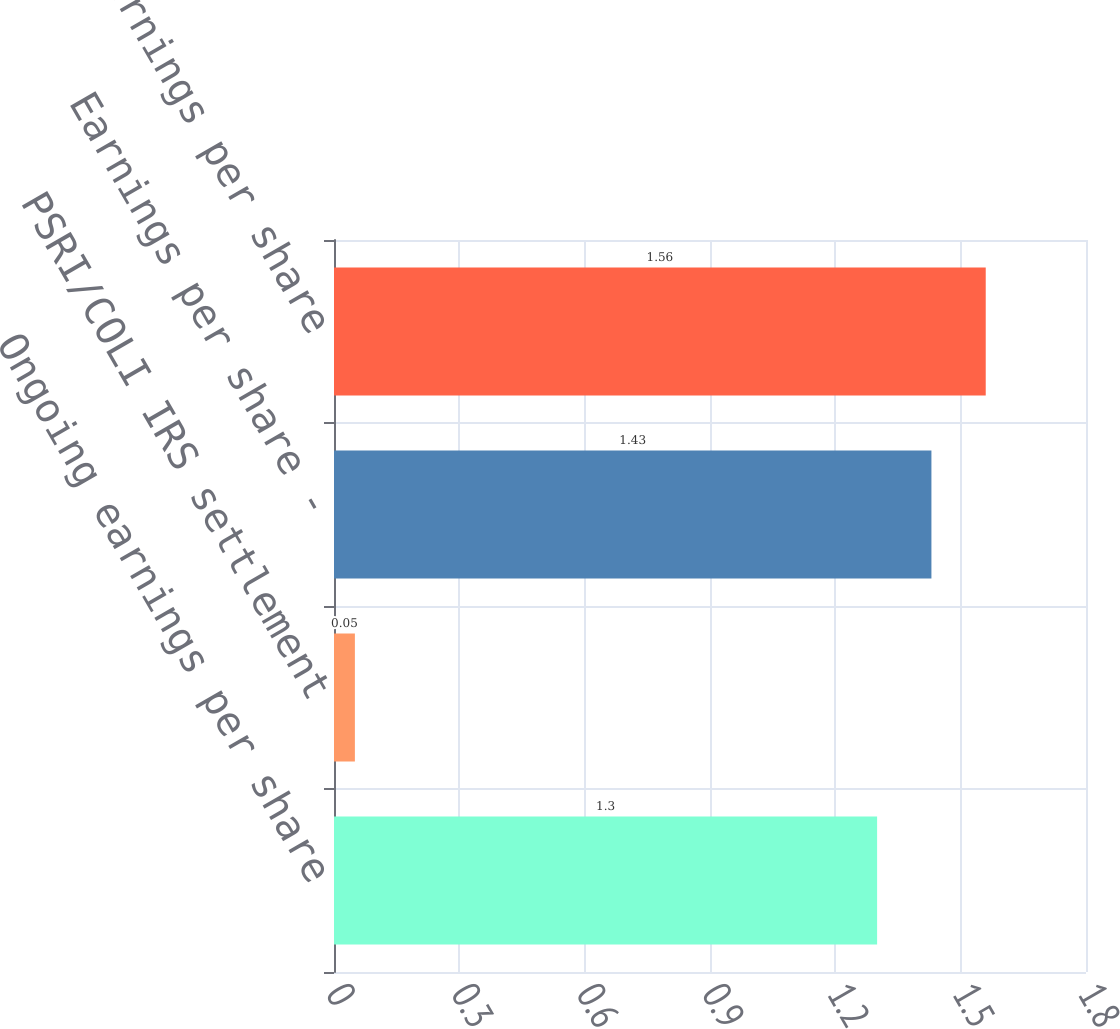<chart> <loc_0><loc_0><loc_500><loc_500><bar_chart><fcel>Ongoing earnings per share<fcel>PSRI/COLI IRS settlement<fcel>Earnings per share -<fcel>Total GAAP earnings per share<nl><fcel>1.3<fcel>0.05<fcel>1.43<fcel>1.56<nl></chart> 